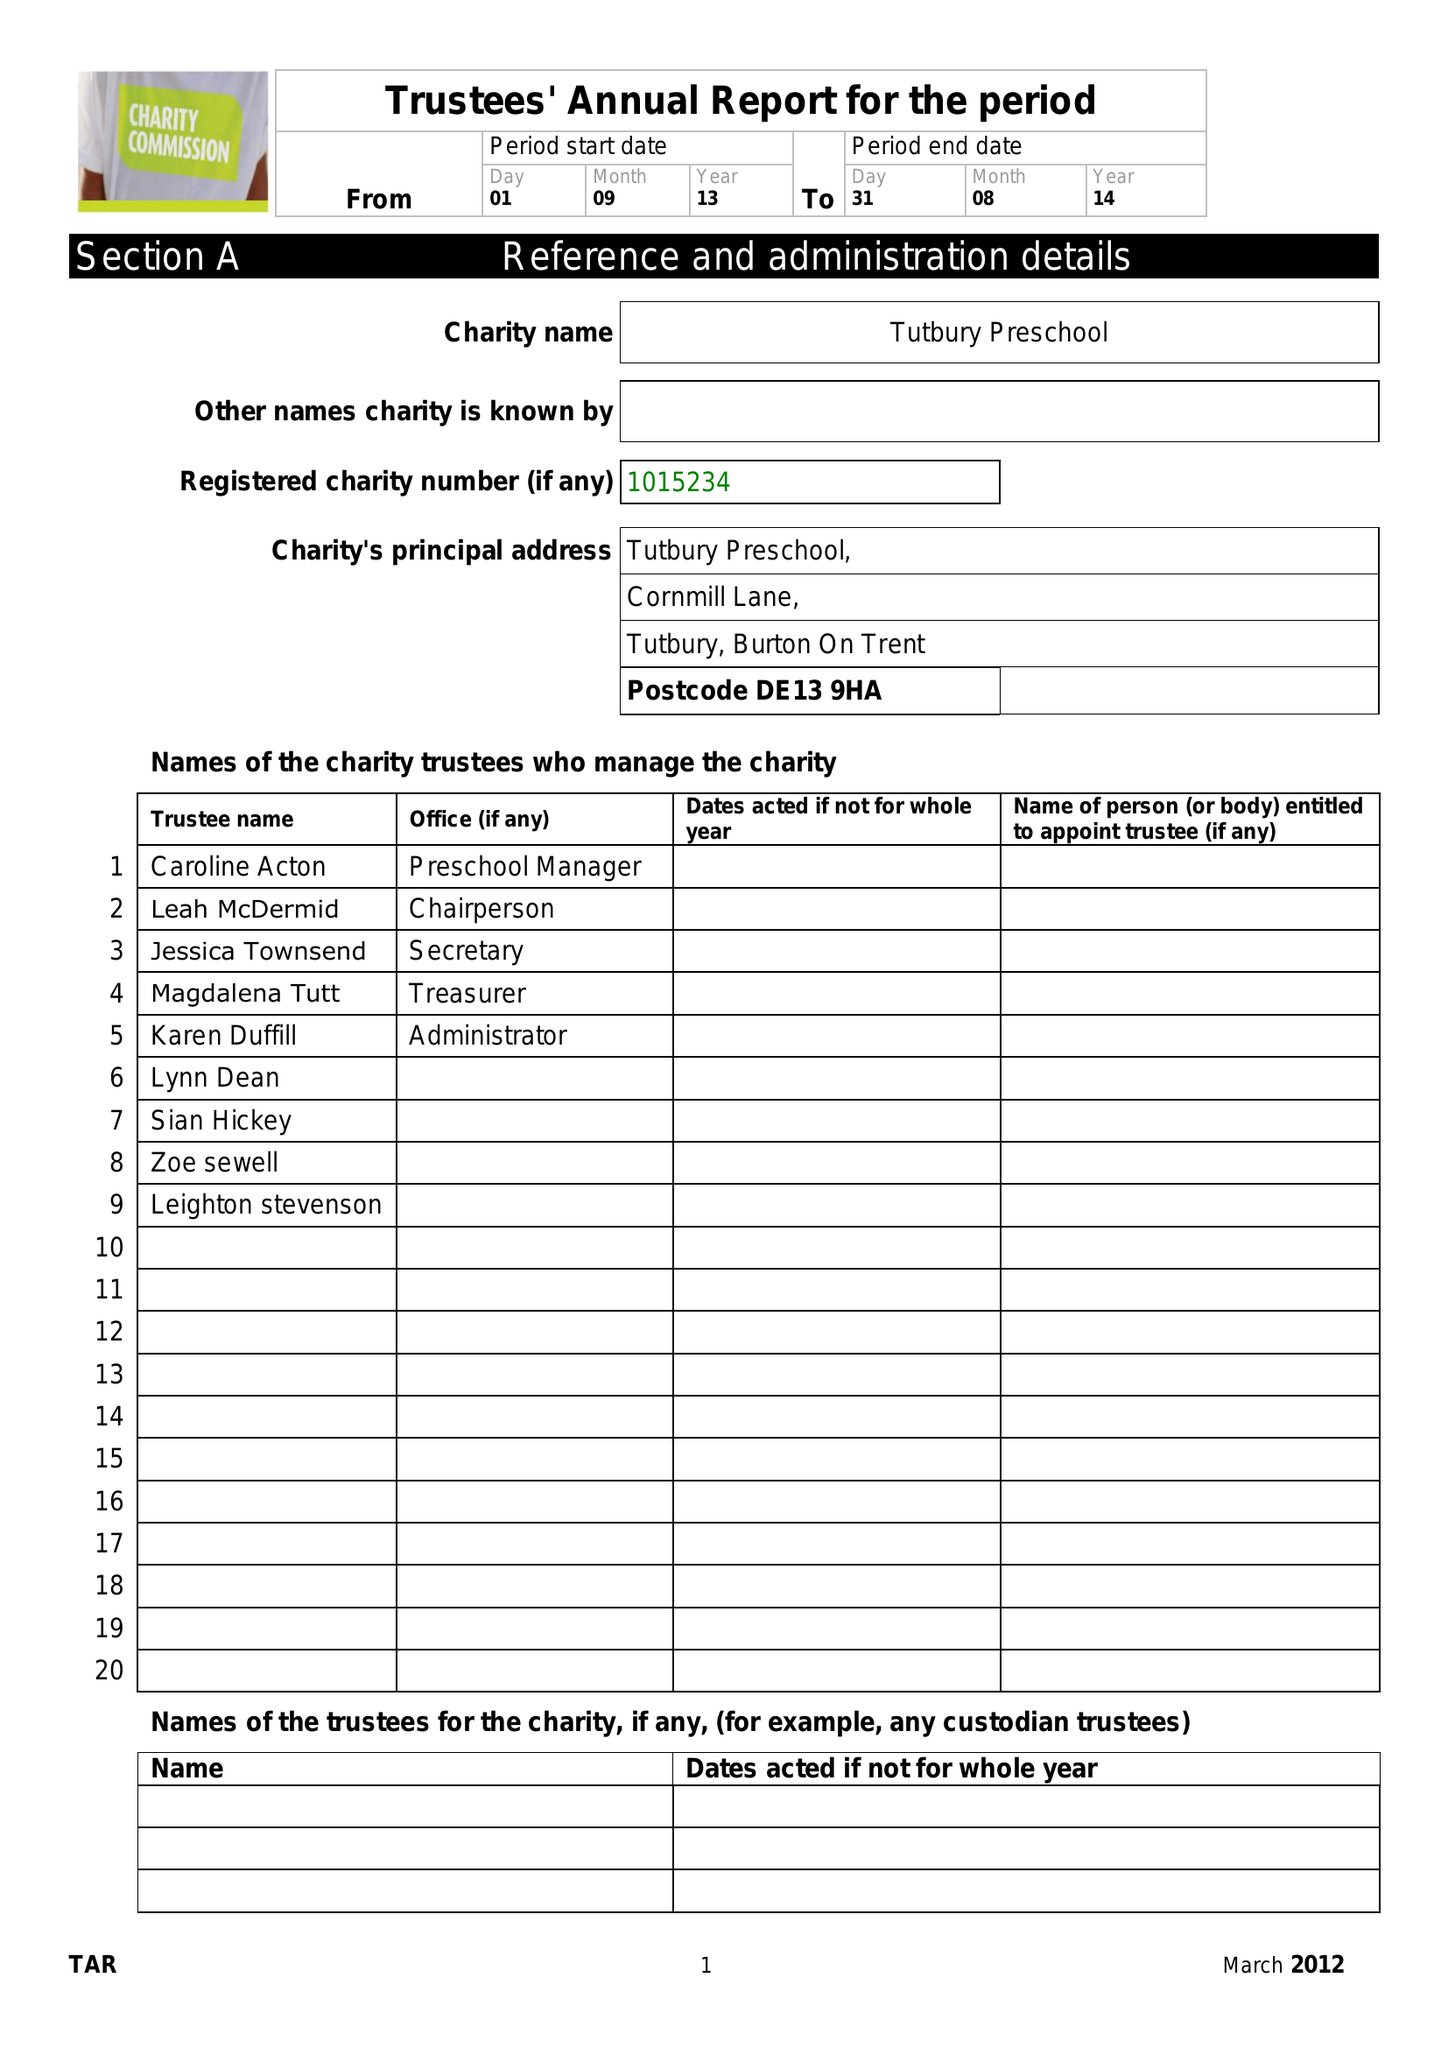What is the value for the address__postcode?
Answer the question using a single word or phrase. DE13 0LE 